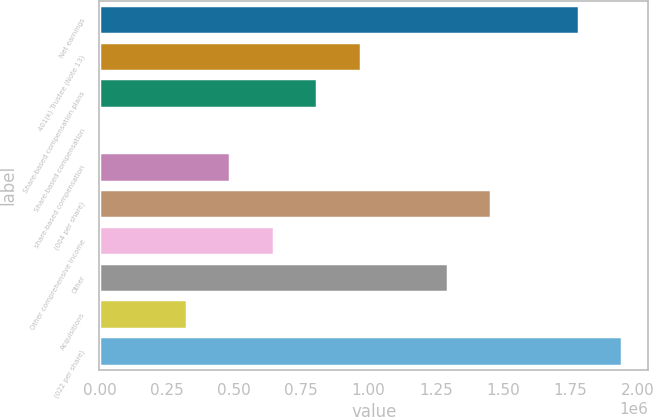Convert chart to OTSL. <chart><loc_0><loc_0><loc_500><loc_500><bar_chart><fcel>Net earnings<fcel>401(k) Trustee (Note 13)<fcel>Share-based compensation plans<fcel>Share-based compensation<fcel>share-based compensation<fcel>(004 per share)<fcel>Other comprehensive income<fcel>Other<fcel>Acquisitions<fcel>(022 per share)<nl><fcel>1.78036e+06<fcel>971104<fcel>809254<fcel>0.27<fcel>485552<fcel>1.45666e+06<fcel>647403<fcel>1.29481e+06<fcel>323702<fcel>1.94221e+06<nl></chart> 